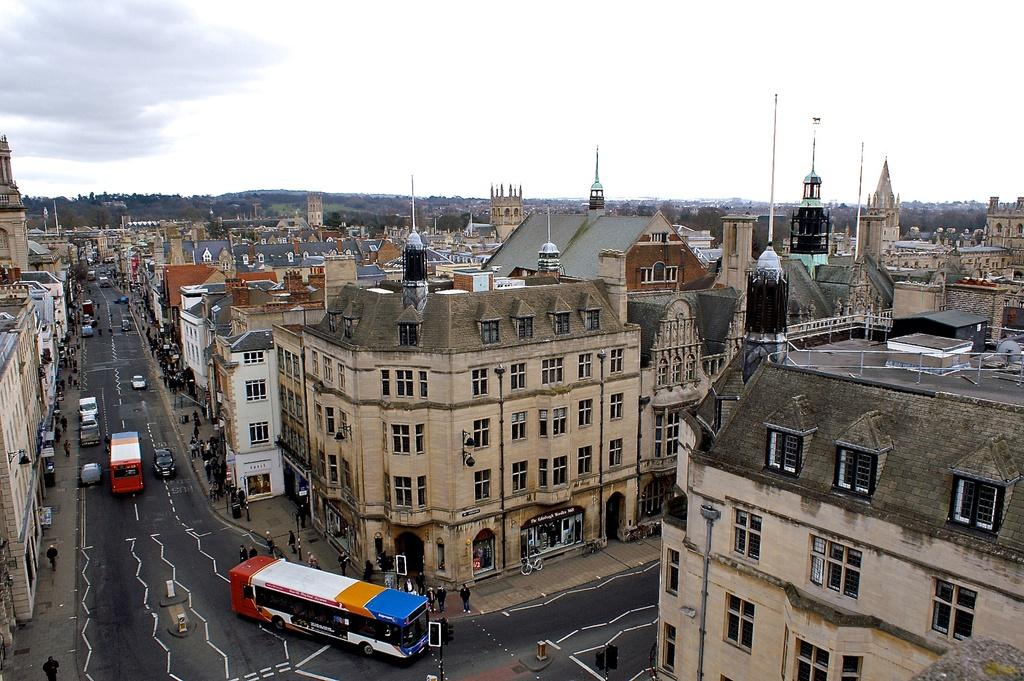What can be seen on the road in the image? There are vehicles on the road in the image. What type of structures are visible in the image? There are buildings with windows in the image. What natural elements are present in the image? Trees are present in the image. Where are the people located in the image? There is a group of people standing on the footpath in the image. What is visible in the background of the image? The sky with clouds is visible in the background of the image. What type of representative is standing next to the baby in the image? There is no representative or baby present in the image. How does the sail affect the movement of the vehicles in the image? There is no sail present in the image, and therefore it does not affect the movement of the vehicles. 